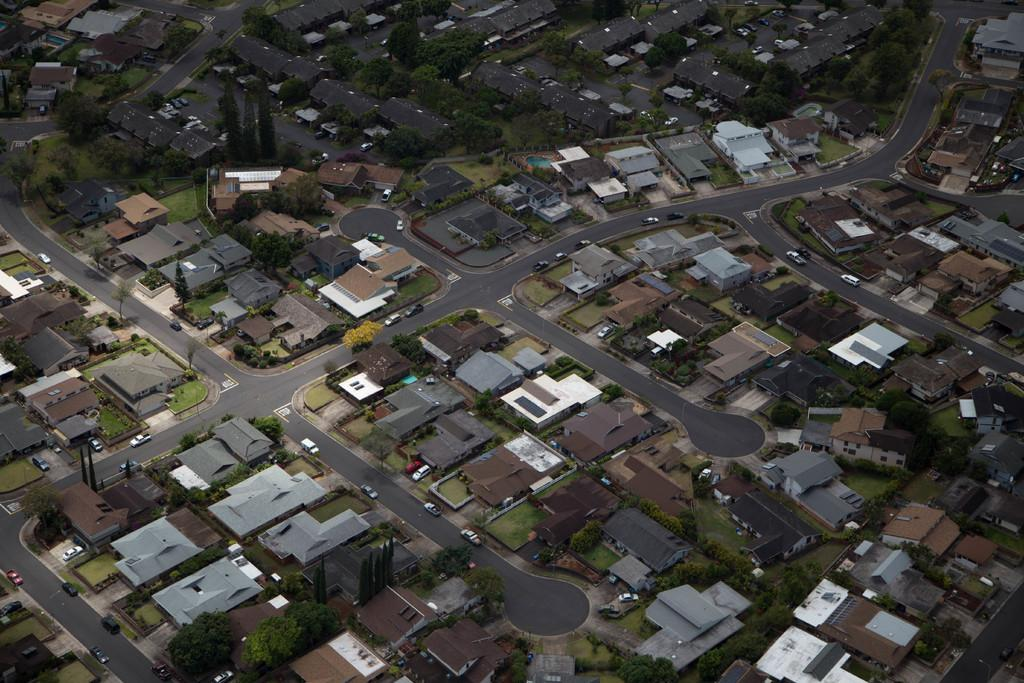What type of structures can be seen in the image? There are many houses in the image. What type of natural elements are present in the image? There are trees in the image. What type of infrastructure is visible in the image? There are roads in the image. What type of man-made objects can be seen in the image? There are vehicles in the image. Can you tell me how many birds are perched on the mailbox in the image? There is no mailbox or bird present in the image. What type of respect is being shown by the vehicles in the image? There is no indication of respect being shown by the vehicles in the image. 